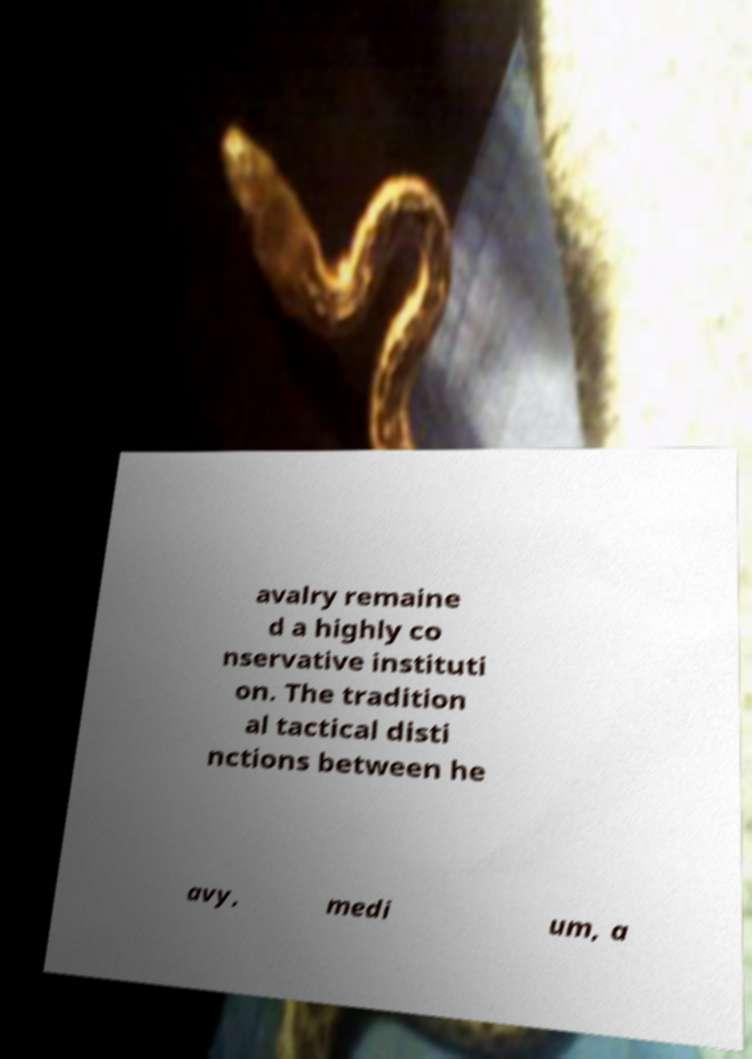Please read and relay the text visible in this image. What does it say? avalry remaine d a highly co nservative instituti on. The tradition al tactical disti nctions between he avy, medi um, a 